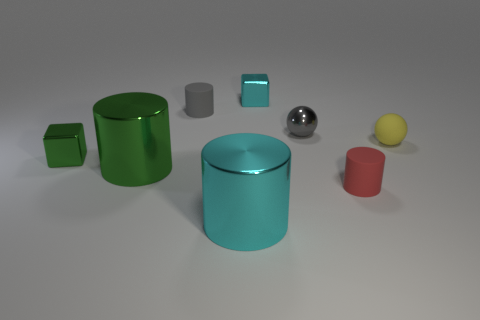How many large cylinders are there, and what colors are they? In the image, there are two large cylinders. One is green with a matte finish, and the other is cyan and appears to have a shiny surface. 